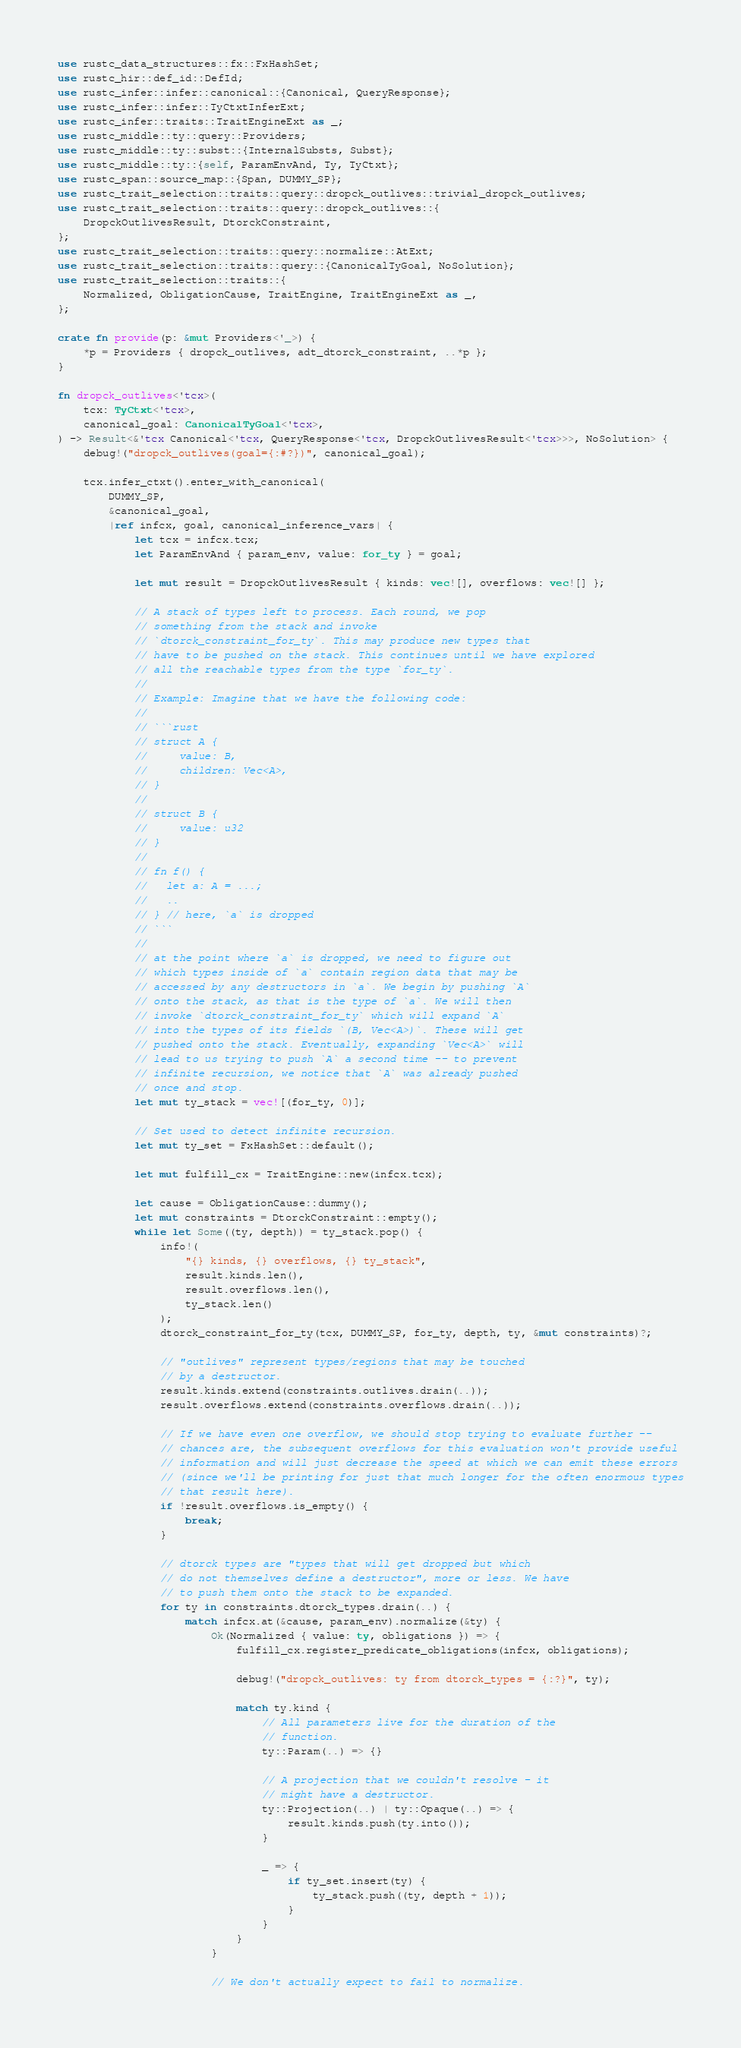Convert code to text. <code><loc_0><loc_0><loc_500><loc_500><_Rust_>use rustc_data_structures::fx::FxHashSet;
use rustc_hir::def_id::DefId;
use rustc_infer::infer::canonical::{Canonical, QueryResponse};
use rustc_infer::infer::TyCtxtInferExt;
use rustc_infer::traits::TraitEngineExt as _;
use rustc_middle::ty::query::Providers;
use rustc_middle::ty::subst::{InternalSubsts, Subst};
use rustc_middle::ty::{self, ParamEnvAnd, Ty, TyCtxt};
use rustc_span::source_map::{Span, DUMMY_SP};
use rustc_trait_selection::traits::query::dropck_outlives::trivial_dropck_outlives;
use rustc_trait_selection::traits::query::dropck_outlives::{
    DropckOutlivesResult, DtorckConstraint,
};
use rustc_trait_selection::traits::query::normalize::AtExt;
use rustc_trait_selection::traits::query::{CanonicalTyGoal, NoSolution};
use rustc_trait_selection::traits::{
    Normalized, ObligationCause, TraitEngine, TraitEngineExt as _,
};

crate fn provide(p: &mut Providers<'_>) {
    *p = Providers { dropck_outlives, adt_dtorck_constraint, ..*p };
}

fn dropck_outlives<'tcx>(
    tcx: TyCtxt<'tcx>,
    canonical_goal: CanonicalTyGoal<'tcx>,
) -> Result<&'tcx Canonical<'tcx, QueryResponse<'tcx, DropckOutlivesResult<'tcx>>>, NoSolution> {
    debug!("dropck_outlives(goal={:#?})", canonical_goal);

    tcx.infer_ctxt().enter_with_canonical(
        DUMMY_SP,
        &canonical_goal,
        |ref infcx, goal, canonical_inference_vars| {
            let tcx = infcx.tcx;
            let ParamEnvAnd { param_env, value: for_ty } = goal;

            let mut result = DropckOutlivesResult { kinds: vec![], overflows: vec![] };

            // A stack of types left to process. Each round, we pop
            // something from the stack and invoke
            // `dtorck_constraint_for_ty`. This may produce new types that
            // have to be pushed on the stack. This continues until we have explored
            // all the reachable types from the type `for_ty`.
            //
            // Example: Imagine that we have the following code:
            //
            // ```rust
            // struct A {
            //     value: B,
            //     children: Vec<A>,
            // }
            //
            // struct B {
            //     value: u32
            // }
            //
            // fn f() {
            //   let a: A = ...;
            //   ..
            // } // here, `a` is dropped
            // ```
            //
            // at the point where `a` is dropped, we need to figure out
            // which types inside of `a` contain region data that may be
            // accessed by any destructors in `a`. We begin by pushing `A`
            // onto the stack, as that is the type of `a`. We will then
            // invoke `dtorck_constraint_for_ty` which will expand `A`
            // into the types of its fields `(B, Vec<A>)`. These will get
            // pushed onto the stack. Eventually, expanding `Vec<A>` will
            // lead to us trying to push `A` a second time -- to prevent
            // infinite recursion, we notice that `A` was already pushed
            // once and stop.
            let mut ty_stack = vec![(for_ty, 0)];

            // Set used to detect infinite recursion.
            let mut ty_set = FxHashSet::default();

            let mut fulfill_cx = TraitEngine::new(infcx.tcx);

            let cause = ObligationCause::dummy();
            let mut constraints = DtorckConstraint::empty();
            while let Some((ty, depth)) = ty_stack.pop() {
                info!(
                    "{} kinds, {} overflows, {} ty_stack",
                    result.kinds.len(),
                    result.overflows.len(),
                    ty_stack.len()
                );
                dtorck_constraint_for_ty(tcx, DUMMY_SP, for_ty, depth, ty, &mut constraints)?;

                // "outlives" represent types/regions that may be touched
                // by a destructor.
                result.kinds.extend(constraints.outlives.drain(..));
                result.overflows.extend(constraints.overflows.drain(..));

                // If we have even one overflow, we should stop trying to evaluate further --
                // chances are, the subsequent overflows for this evaluation won't provide useful
                // information and will just decrease the speed at which we can emit these errors
                // (since we'll be printing for just that much longer for the often enormous types
                // that result here).
                if !result.overflows.is_empty() {
                    break;
                }

                // dtorck types are "types that will get dropped but which
                // do not themselves define a destructor", more or less. We have
                // to push them onto the stack to be expanded.
                for ty in constraints.dtorck_types.drain(..) {
                    match infcx.at(&cause, param_env).normalize(&ty) {
                        Ok(Normalized { value: ty, obligations }) => {
                            fulfill_cx.register_predicate_obligations(infcx, obligations);

                            debug!("dropck_outlives: ty from dtorck_types = {:?}", ty);

                            match ty.kind {
                                // All parameters live for the duration of the
                                // function.
                                ty::Param(..) => {}

                                // A projection that we couldn't resolve - it
                                // might have a destructor.
                                ty::Projection(..) | ty::Opaque(..) => {
                                    result.kinds.push(ty.into());
                                }

                                _ => {
                                    if ty_set.insert(ty) {
                                        ty_stack.push((ty, depth + 1));
                                    }
                                }
                            }
                        }

                        // We don't actually expect to fail to normalize.</code> 